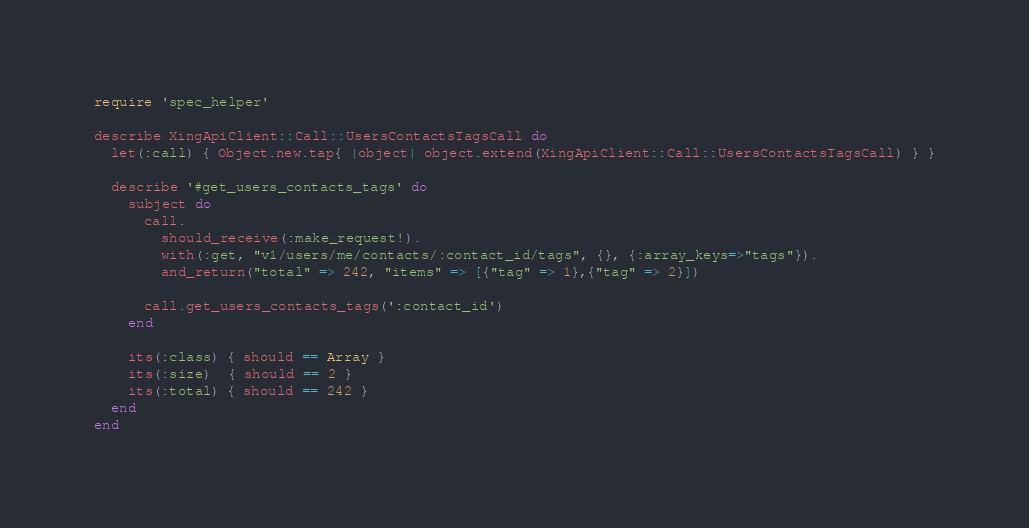Convert code to text. <code><loc_0><loc_0><loc_500><loc_500><_Ruby_>require 'spec_helper'

describe XingApiClient::Call::UsersContactsTagsCall do
  let(:call) { Object.new.tap{ |object| object.extend(XingApiClient::Call::UsersContactsTagsCall) } }

  describe '#get_users_contacts_tags' do
    subject do
      call.
        should_receive(:make_request!).
        with(:get, "v1/users/me/contacts/:contact_id/tags", {}, {:array_keys=>"tags"}).
        and_return("total" => 242, "items" => [{"tag" => 1},{"tag" => 2}])

      call.get_users_contacts_tags(':contact_id')
    end

    its(:class) { should == Array }
    its(:size)  { should == 2 }
    its(:total) { should == 242 }
  end
end
</code> 